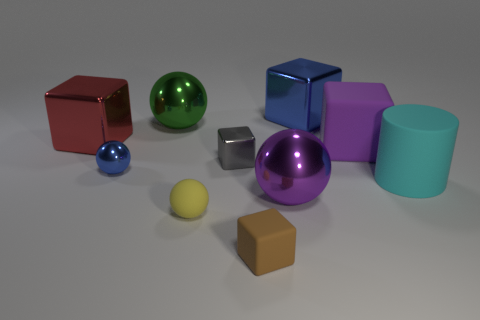How many other things are the same shape as the big green thing?
Ensure brevity in your answer.  3. Do the brown thing and the purple block have the same size?
Offer a very short reply. No. There is a big metallic cube that is in front of the blue thing on the right side of the metal block that is in front of the purple rubber block; what color is it?
Make the answer very short. Red. How many balls are the same color as the small matte block?
Your answer should be very brief. 0. How many small objects are matte balls or brown things?
Your response must be concise. 2. Are there any yellow objects that have the same shape as the big purple rubber object?
Provide a short and direct response. No. Do the tiny blue shiny object and the gray metallic object have the same shape?
Your answer should be compact. No. There is a big metallic ball behind the big metal ball in front of the large cyan cylinder; what is its color?
Keep it short and to the point. Green. What color is the rubber cylinder that is the same size as the blue cube?
Your answer should be compact. Cyan. What number of metallic objects are either small red objects or large purple balls?
Keep it short and to the point. 1. 